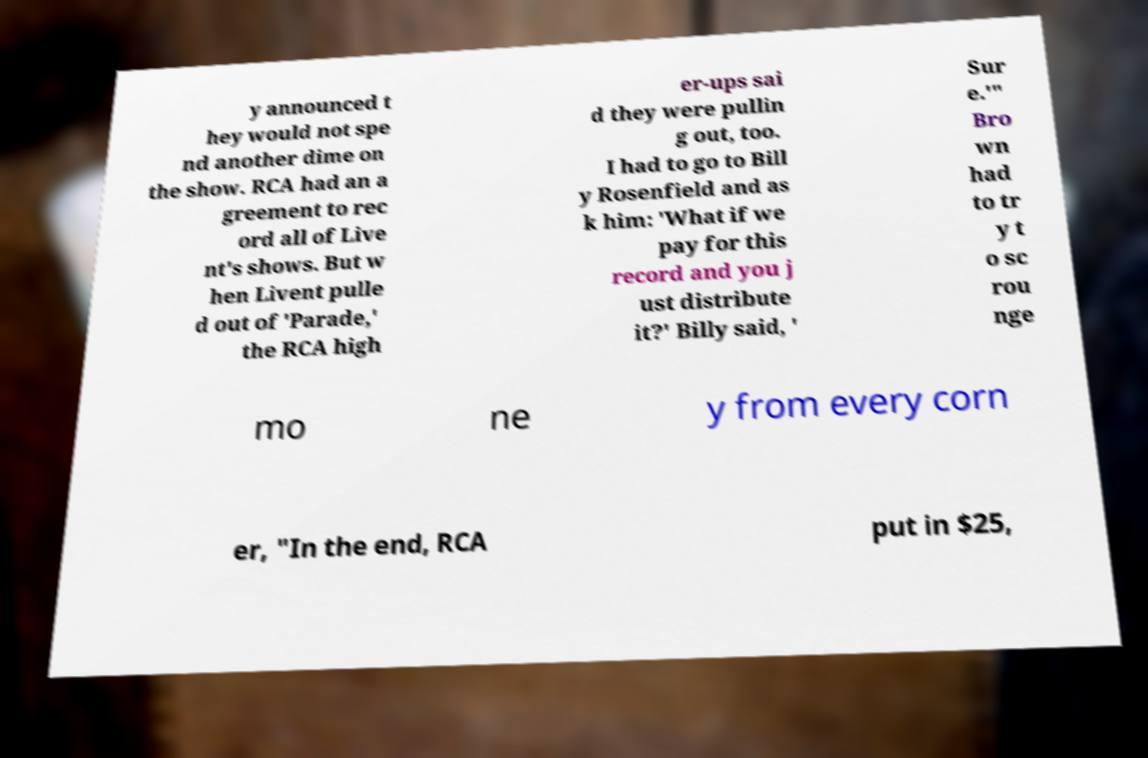What messages or text are displayed in this image? I need them in a readable, typed format. y announced t hey would not spe nd another dime on the show. RCA had an a greement to rec ord all of Live nt's shows. But w hen Livent pulle d out of 'Parade,' the RCA high er-ups sai d they were pullin g out, too. I had to go to Bill y Rosenfield and as k him: 'What if we pay for this record and you j ust distribute it?' Billy said, ' Sur e.'" Bro wn had to tr y t o sc rou nge mo ne y from every corn er, "In the end, RCA put in $25, 